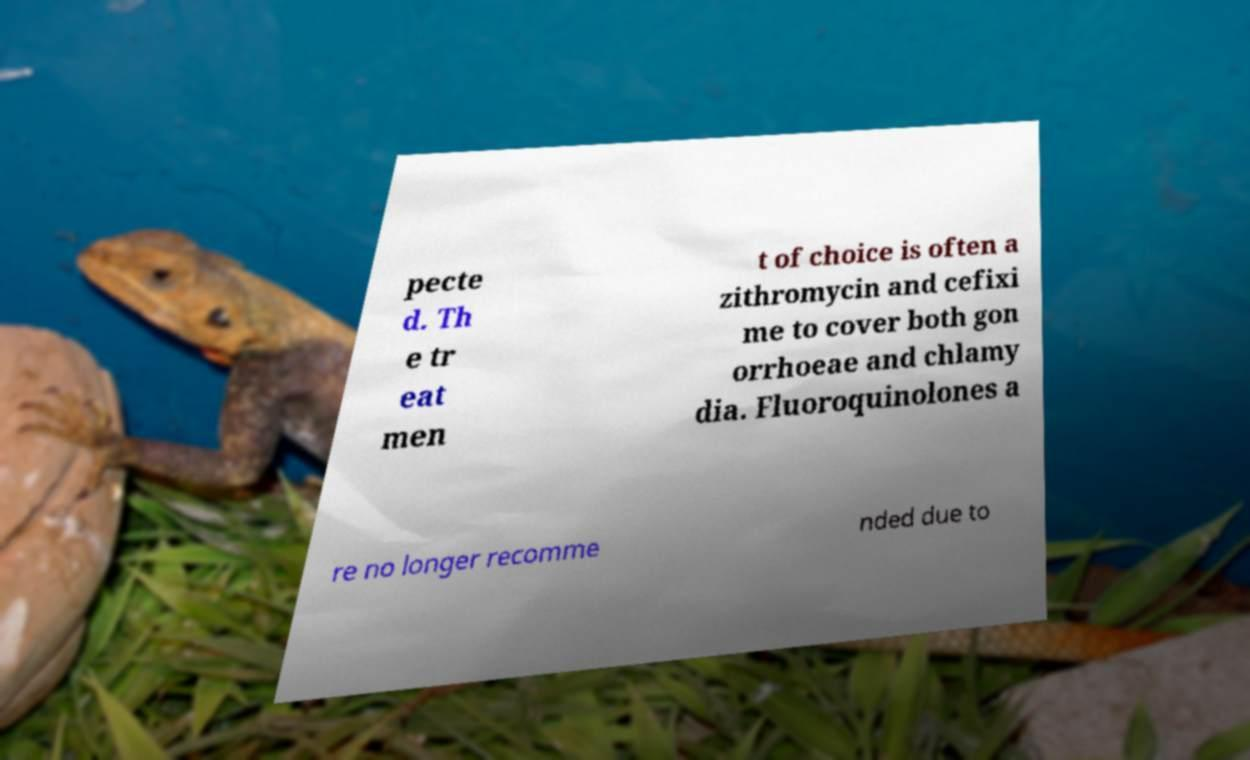Could you extract and type out the text from this image? pecte d. Th e tr eat men t of choice is often a zithromycin and cefixi me to cover both gon orrhoeae and chlamy dia. Fluoroquinolones a re no longer recomme nded due to 